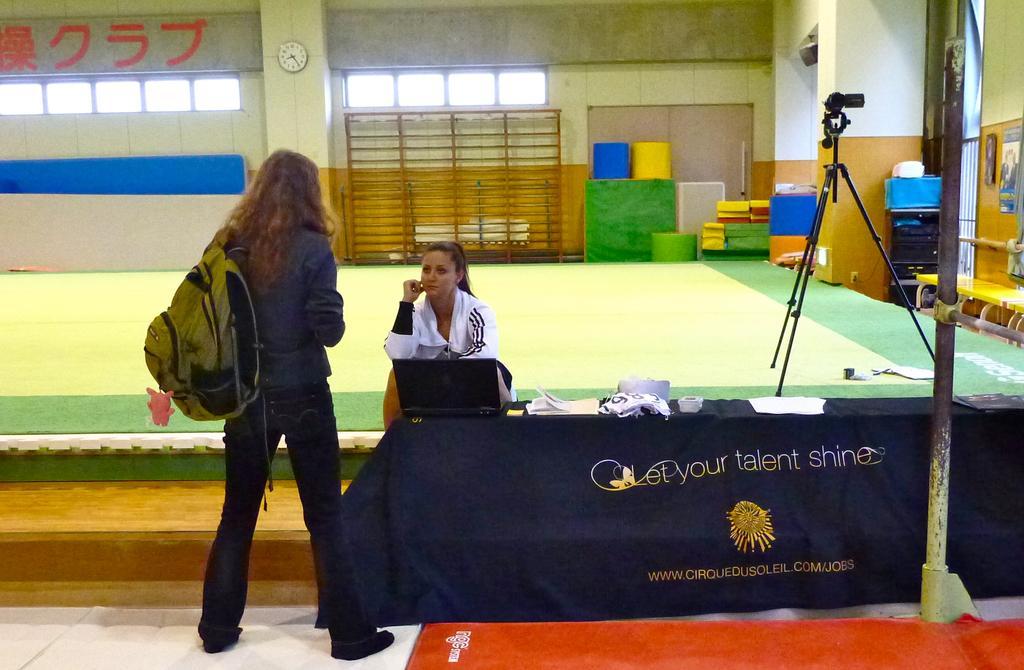Could you give a brief overview of what you see in this image? In the center of the image there are two girls. There is a table with cloth on it. There is a laptop on the table. In the background of the image there is a wall. There is a clock. To the right side of the image there is a video recorder. At the bottom of the image there is a carpet. 